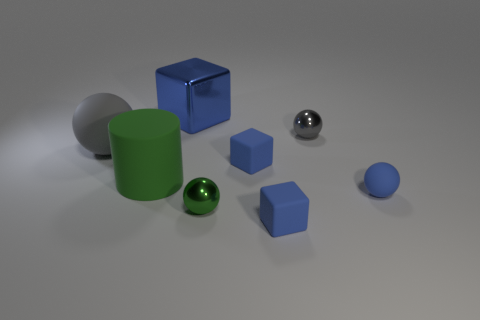Subtract 1 balls. How many balls are left? 3 Subtract all yellow spheres. Subtract all gray cylinders. How many spheres are left? 4 Add 1 tiny shiny spheres. How many objects exist? 9 Subtract all cubes. How many objects are left? 5 Add 6 cylinders. How many cylinders exist? 7 Subtract 0 red spheres. How many objects are left? 8 Subtract all shiny things. Subtract all small blocks. How many objects are left? 3 Add 8 small matte balls. How many small matte balls are left? 9 